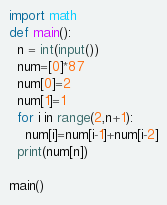Convert code to text. <code><loc_0><loc_0><loc_500><loc_500><_Python_>import math
def main():
  n = int(input())
  num=[0]*87
  num[0]=2
  num[1]=1
  for i in range(2,n+1):
    num[i]=num[i-1]+num[i-2]
  print(num[n])
    
main()
</code> 